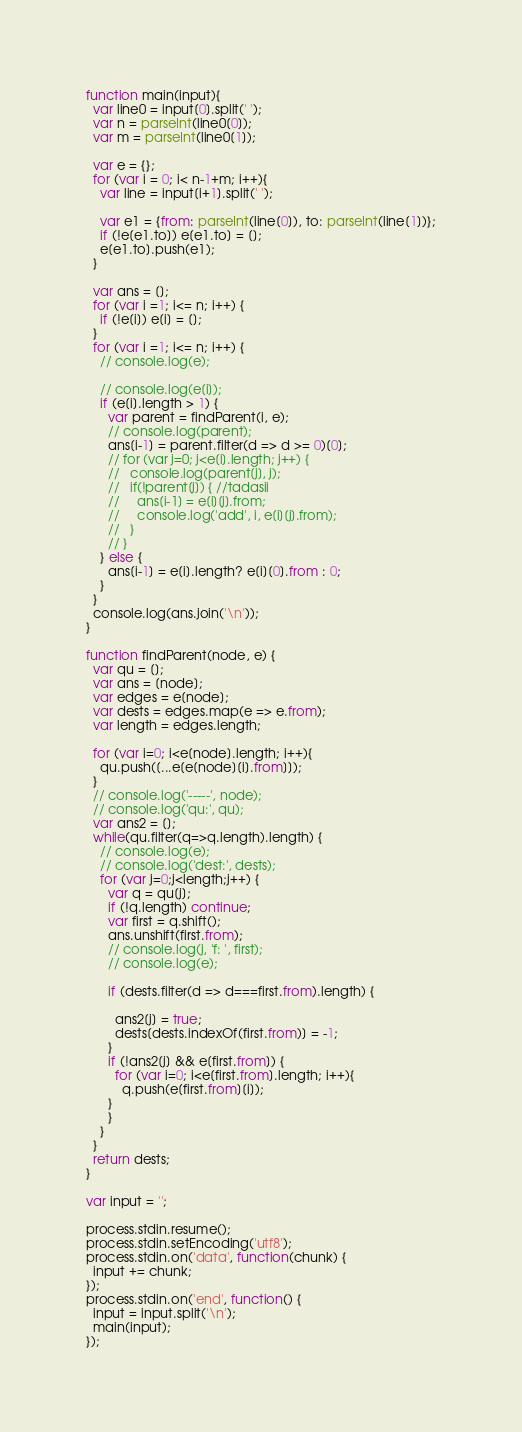<code> <loc_0><loc_0><loc_500><loc_500><_JavaScript_>function main(input){
  var line0 = input[0].split(' ');
  var n = parseInt(line0[0]);
  var m = parseInt(line0[1]);
  
  var e = {};
  for (var i = 0; i< n-1+m; i++){
    var line = input[i+1].split(' ');

    var e1 = {from: parseInt(line[0]), to: parseInt(line[1])};
    if (!e[e1.to]) e[e1.to] = [];
    e[e1.to].push(e1);
  }

  var ans = [];
  for (var i =1; i<= n; i++) {
    if (!e[i]) e[i] = [];
  }
  for (var i =1; i<= n; i++) {
    // console.log(e);
    
    // console.log(e[i]);
    if (e[i].length > 1) {
      var parent = findParent(i, e);
      // console.log(parent);
      ans[i-1] = parent.filter(d => d >= 0)[0];
      // for (var j=0; j<e[i].length; j++) {
      //   console.log(parent[j], j);
      //   if(!parent[j]) { //tadasii
      //     ans[i-1] = e[i][j].from;
      //     console.log('add', i, e[i][j].from);
      //   }
      // }
    } else {
      ans[i-1] = e[i].length? e[i][0].from : 0;
    }
  }
  console.log(ans.join('\n'));
}

function findParent(node, e) {
  var qu = [];
  var ans = [node];
  var edges = e[node];
  var dests = edges.map(e => e.from);
  var length = edges.length;

  for (var i=0; i<e[node].length; i++){
    qu.push([...e[e[node][i].from]]);
  }
  // console.log('-----', node);
  // console.log('qu:', qu);
  var ans2 = [];
  while(qu.filter(q=>q.length).length) {
    // console.log(e);
    // console.log('dest:', dests);
    for (var j=0;j<length;j++) {
      var q = qu[j];
      if (!q.length) continue;
      var first = q.shift();
      ans.unshift(first.from);
      // console.log(j, 'f: ', first);
      // console.log(e);

      if (dests.filter(d => d===first.from).length) {

        ans2[j] = true;
        dests[dests.indexOf(first.from)] = -1;
      }
      if (!ans2[j] && e[first.from]) {
        for (var i=0; i<e[first.from].length; i++){
          q.push(e[first.from][i]);
      }
      }
    }
  }
  return dests;
}

var input = '';

process.stdin.resume();
process.stdin.setEncoding('utf8');
process.stdin.on('data', function(chunk) {
  input += chunk;
});
process.stdin.on('end', function() {
  input = input.split('\n');
  main(input);
});
</code> 